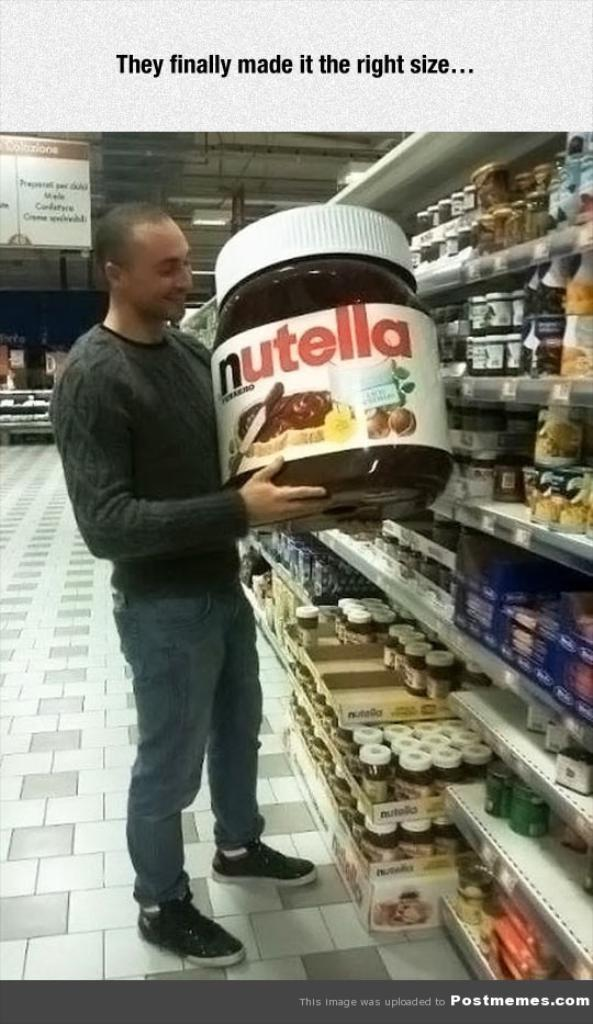<image>
Write a terse but informative summary of the picture. A man is holding a GIANT Nutella jar. 